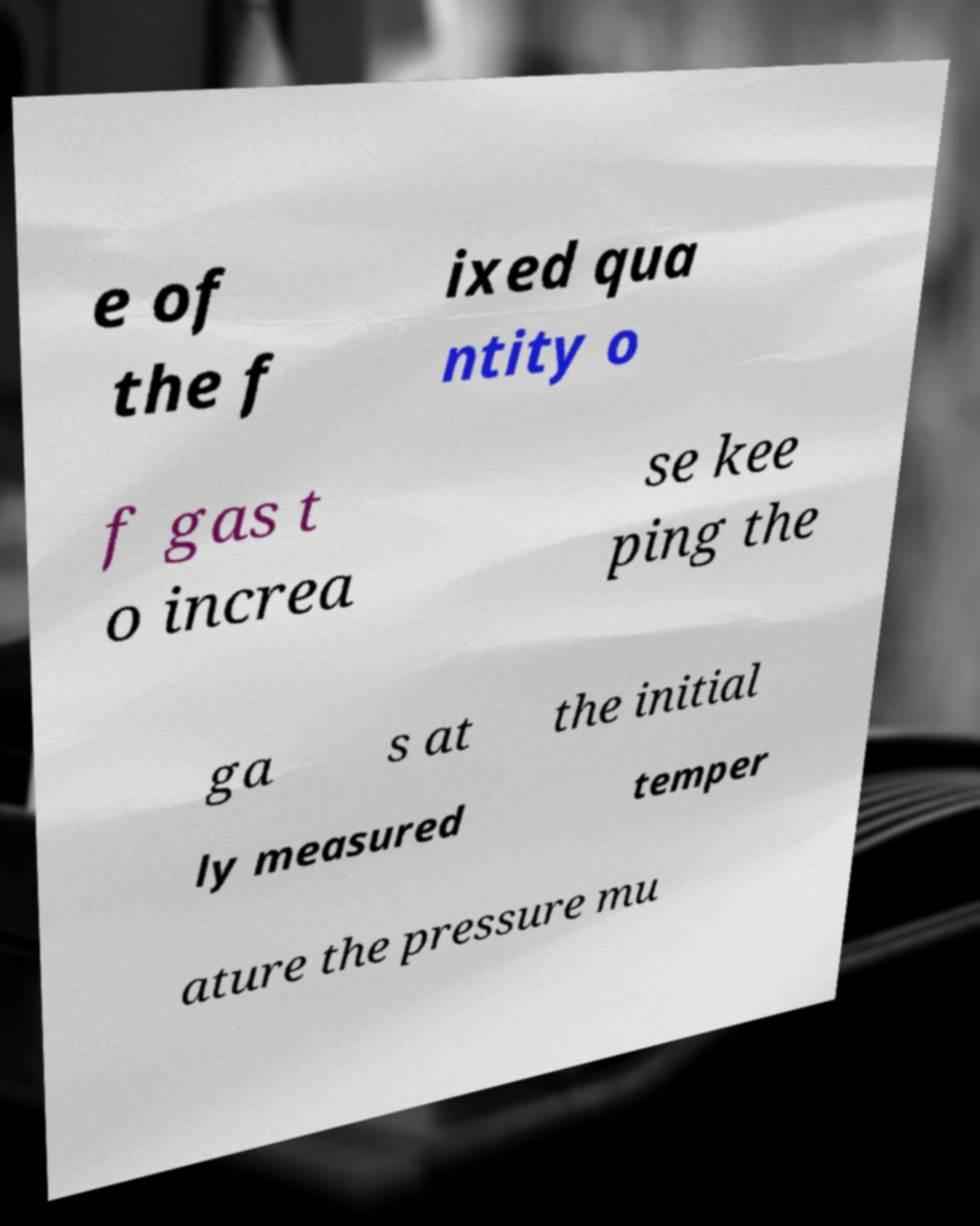For documentation purposes, I need the text within this image transcribed. Could you provide that? e of the f ixed qua ntity o f gas t o increa se kee ping the ga s at the initial ly measured temper ature the pressure mu 